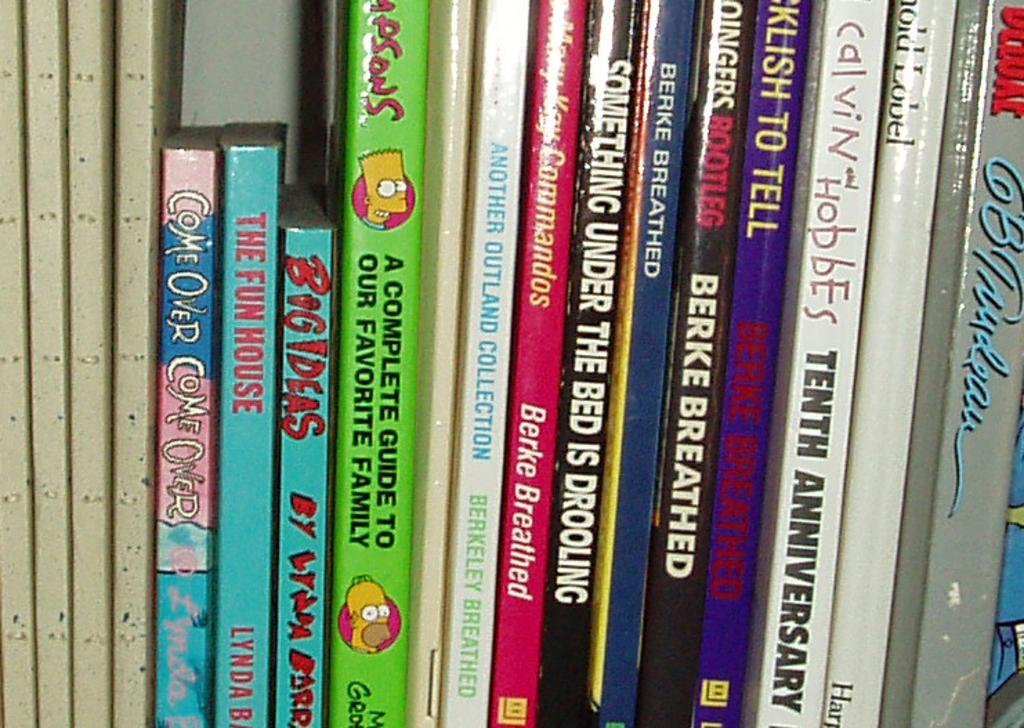<image>
Describe the image concisely. Books next to one another with one saying "The Fun House". 